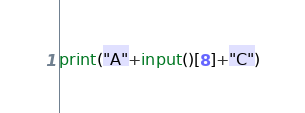<code> <loc_0><loc_0><loc_500><loc_500><_Python_>print("A"+input()[8]+"C")</code> 